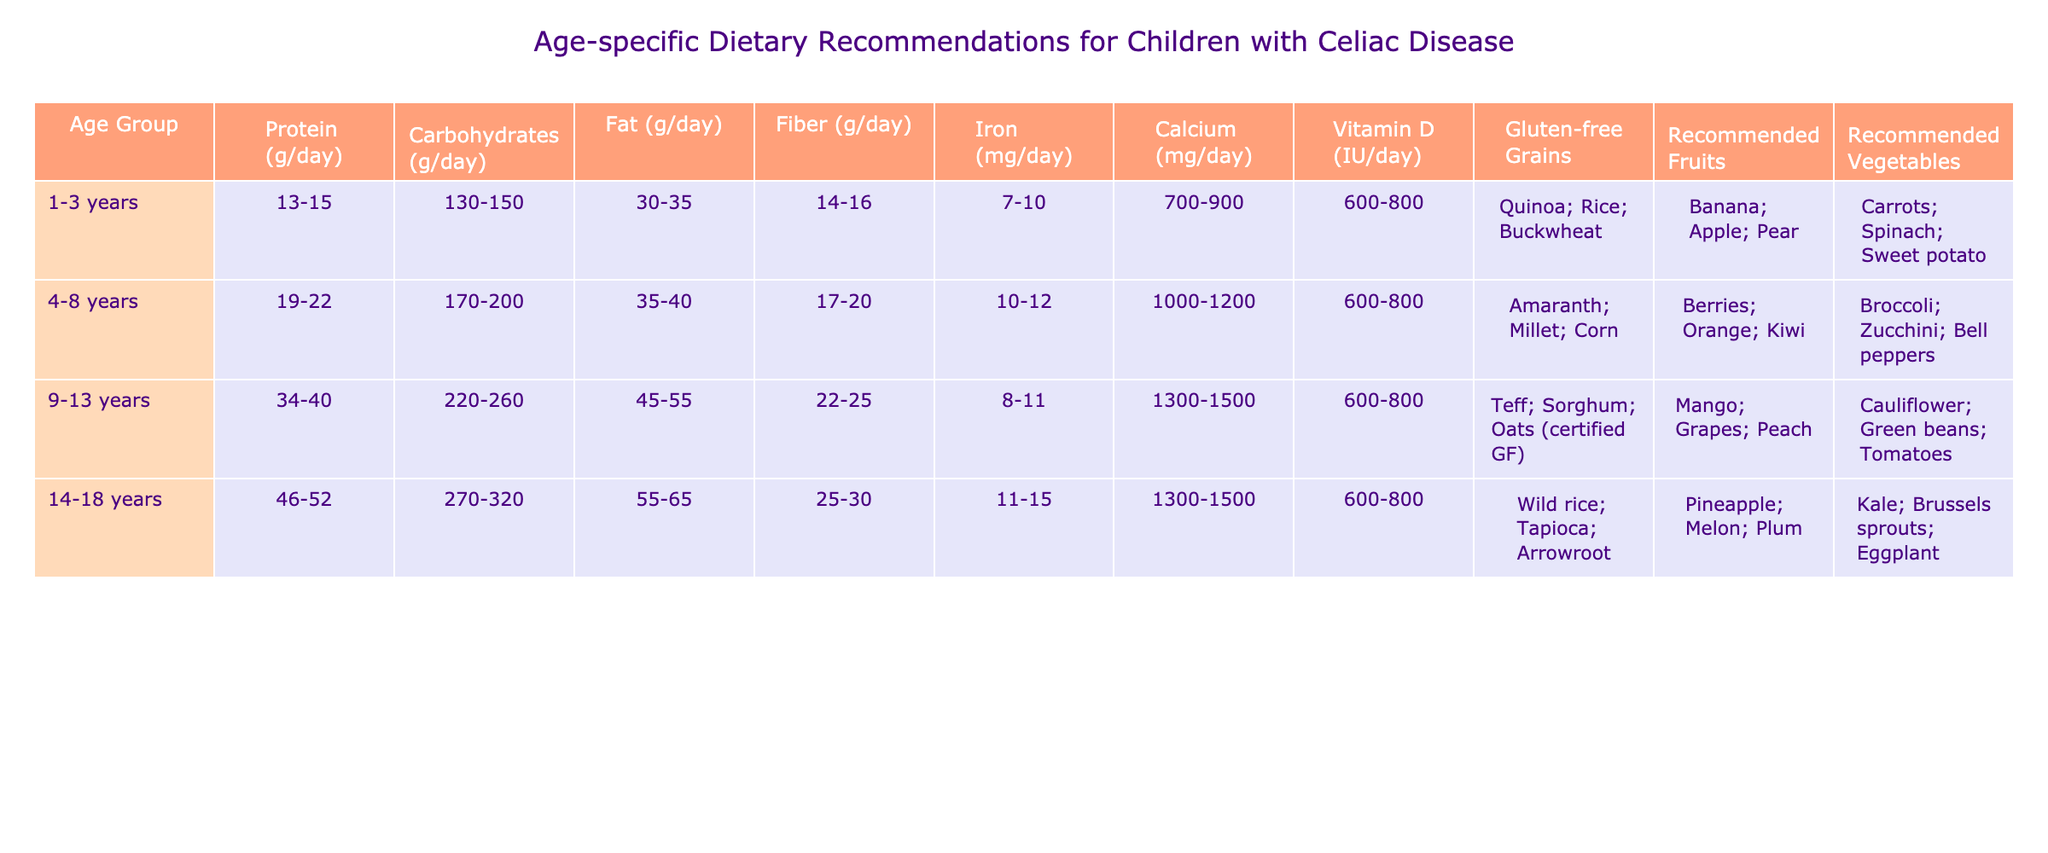What is the recommended daily protein intake for children aged 4-8 years? According to the table, the recommended protein intake for the 4-8 age group is listed as 19-22 grams per day.
Answer: 19-22 grams Which age group has the highest recommended daily carbohydrate intake? The table shows that the 14-18 years age group has the highest intake for carbohydrates at 270-320 grams per day.
Answer: 270-320 grams What is the recommended fiber intake for children aged 1-3 years? The table specifies that children aged 1-3 years should have a fiber intake of 14-16 grams per day.
Answer: 14-16 grams Is the recommended iron intake for 9-13 years old higher than for 1-3 years old? Yes, the recommended iron intake for 9-13 years is 8-11 mg/day, while for 1-3 years it is 7-10 mg/day, so it is indeed higher.
Answer: Yes What is the average calcium intake for all age groups listed in the table? The calcium intakes for the age groups are 700-900, 1000-1200, 1300-1500, and 1300-1500 mg/day. Calculating the average of the lower and upper limits: (700 + 1000 + 1300 + 1300) / 4 = 1075 mg (for lower limits) and (900 + 1200 + 1500 + 1500) / 4 = 1350 mg (for upper limits). Thus, the average intake is 1075 - 1350 mg.
Answer: 1075 - 1350 mg What are the recommended gluten-free grains for children aged 9-13 years? The table indicates that for the 9-13 years age group, the recommended gluten-free grains are Teff, Sorghum, and certified gluten-free Oats.
Answer: Teff; Sorghum; Oats (certified GF) Which age group is recommended to consume 55-65 grams of fat per day? The table clearly shows that the 14-18 years age group has the recommended intake of 55-65 grams of fat per day.
Answer: 14-18 years Are broccoli and zucchini recommended vegetables for children aged 4-8 years? Yes, the table indicates that for the 4-8 years age group, broccoli and zucchini are listed as recommended vegetables.
Answer: Yes What is the total recommended fat intake for children aged 1-3 and 4-8 years combined? The total fat intake for 1-3 years is 30-35 grams and for 4-8 years is 35-40 grams. Adding the lower limits gives 30 + 35 = 65 grams, and the upper limits give 35 + 40 = 75 grams, therefore the combined total is 65-75 grams.
Answer: 65-75 grams What is the difference in the recommended iron intake between 9-13 years and 4-8 years? For 9-13 years, the recommended iron intake is 8-11 mg/day, while for 4-8 years it is 10-12 mg/day. The differences in lower limits are 10 - 8 = 2 mg, and for upper limits, it is 12 - 11 = 1 mg, meaning there is a range of difference of 1-2 mg depending on the specific recommendations.
Answer: 1-2 mg Which recommended fruit is common for all age groups? By examining the table, it appears that there is no fruit listed in each age group that is common among all of them; each group has different recommended fruits.
Answer: No 